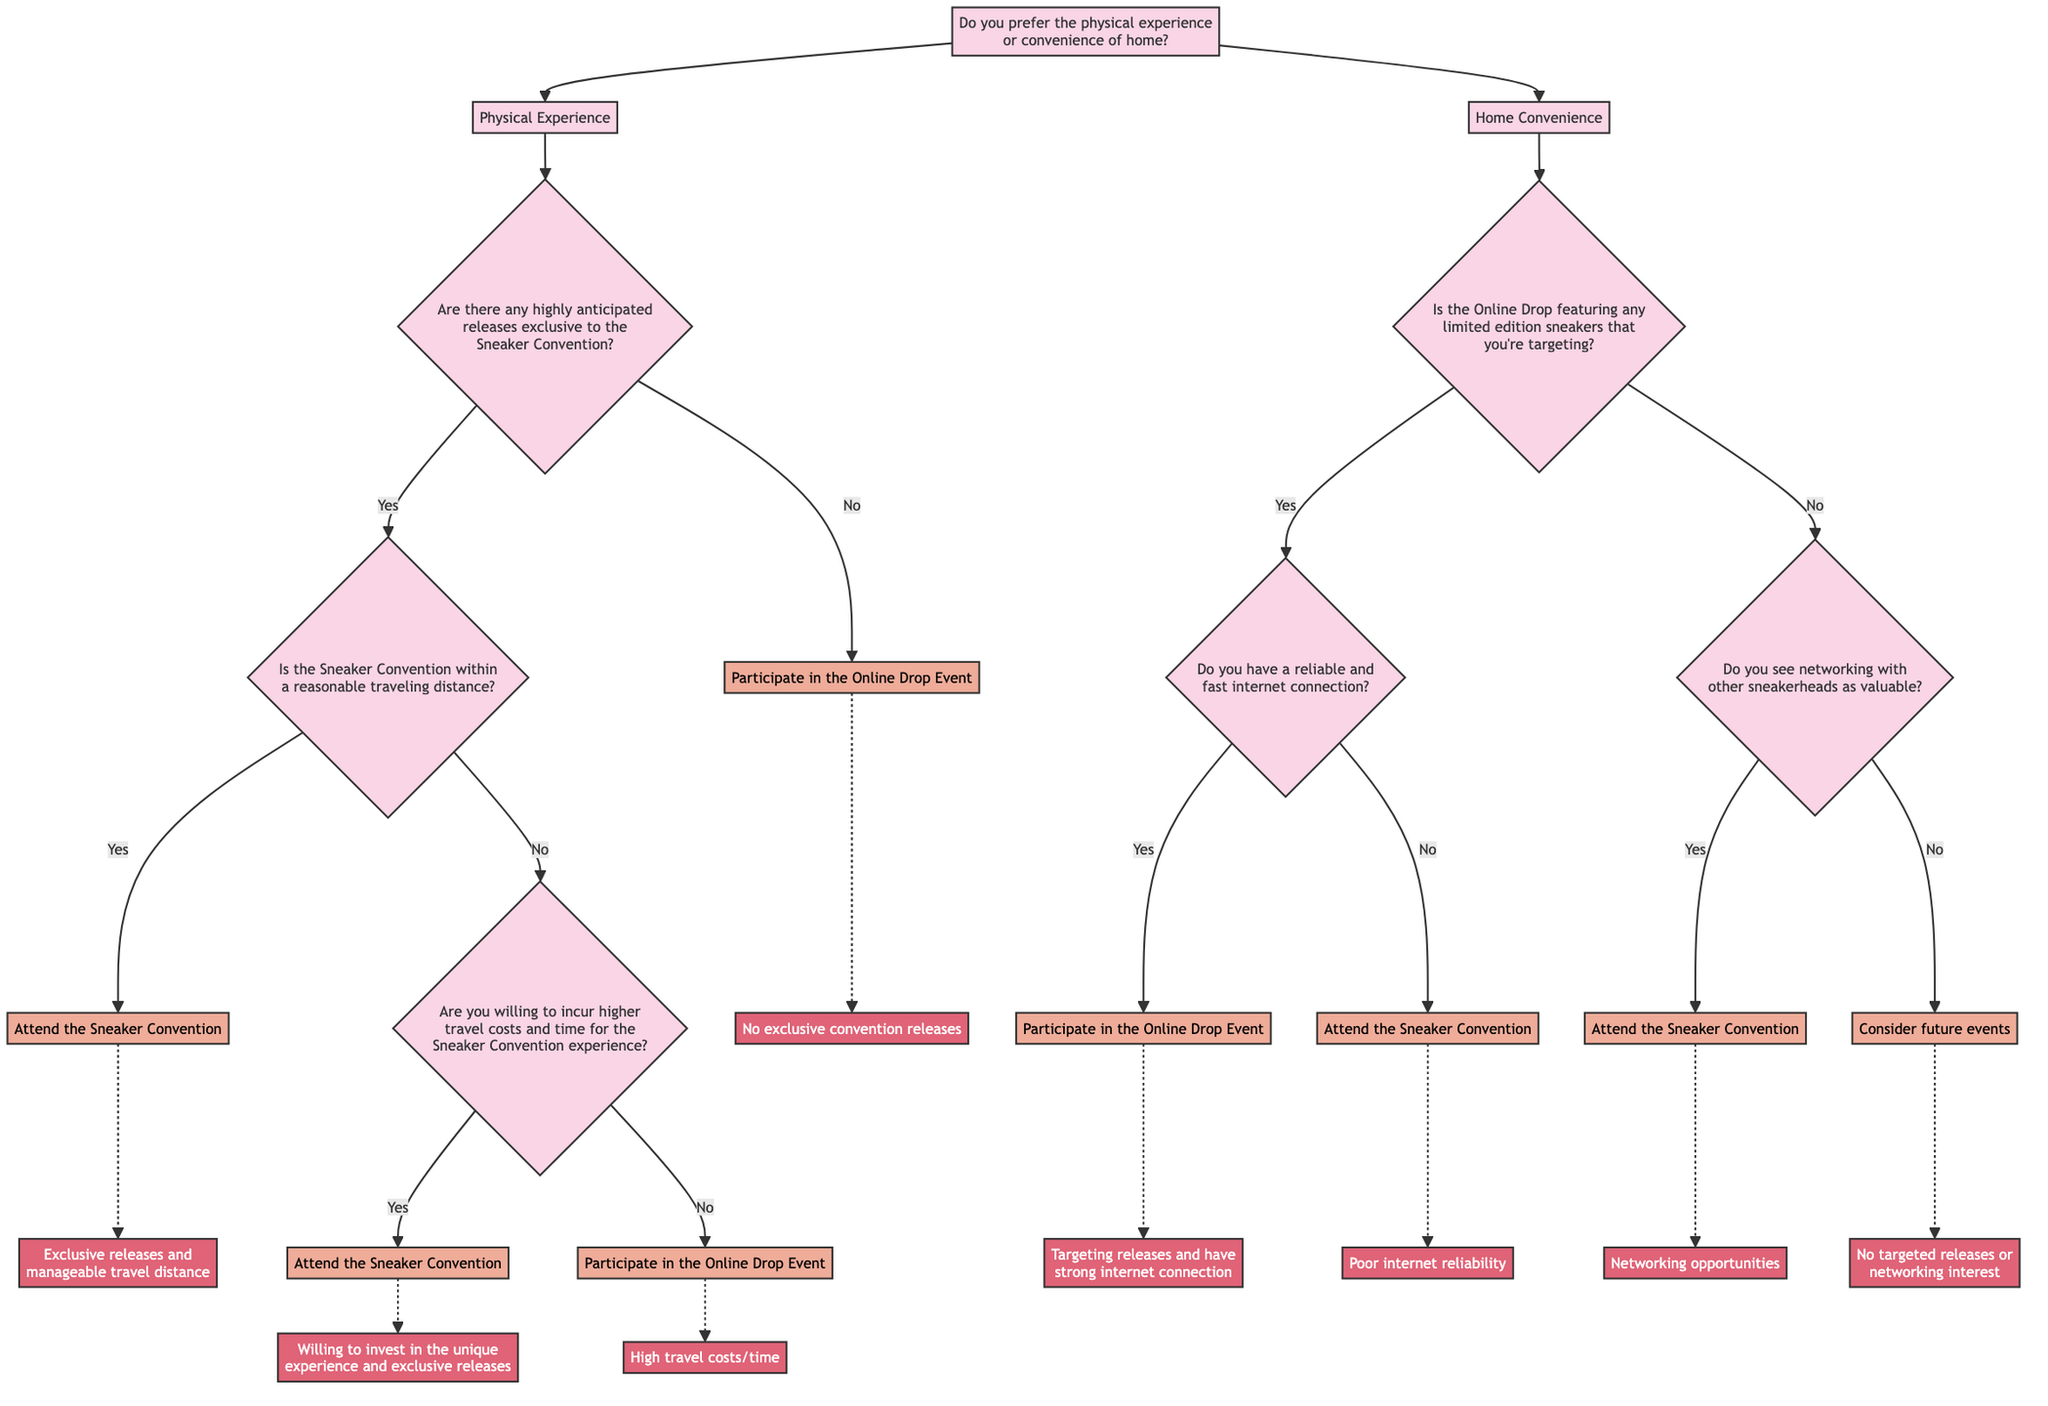What is the first question asked in the decision tree? The first question asked in the decision tree is "Do you prefer the physical experience or convenience of home?" as it initiates the decision-making process for attending either event.
Answer: Do you prefer the physical experience or convenience of home? How many total actions are indicated in the decision tree? By counting the unique actions represented in the diagram, there are five total actions: Attend the Sneaker Convention, Participate in the Online Drop Event, Consider future events, Attend the Sneaker Convention, and Participate in the Online Drop Event.
Answer: Five What is the path taken if someone prefers physical experience and is willing to incur higher travel costs? Starting at the first question, if the person prefers the physical experience, they are led to the question about exclusive releases. If they confirm exclusive releases and indicate higher travel cost willingness, the final action is to attend the Sneaker Convention.
Answer: Attend the Sneaker Convention What happens if the online drop features no limited edition sneakers? If there are no limited edition sneakers, the decision tree leads to evaluating the value of networking with other sneakerheads, which can further guide the decision to attend the Sneaker Convention or consider future events.
Answer: Consider future events If someone has a reliable internet connection, which action do they take when targeting online drop sneakers? If the person is targeting limited edition sneakers in the online drop and has a reliable internet connection, the decision tree directs them to participate in the online drop event.
Answer: Participate in the Online Drop Event What is the specific action taken if the Sneaker Convention is not within reasonable traveling distance and the person is not willing to incur higher costs? In this scenario, where the convention is not within a reasonable distance and the person is unwilling to take on higher travel costs, the decision tree indicates they should participate in the online drop event due to the high travel costs and time.
Answer: Participate in the Online Drop Event What value does the decision tree place on networking with other sneakerheads? The diagram indicates that if someone sees networking with other sneakerheads as valuable, they are guided to attend the Sneaker Convention, highlighting its importance in the decision-making process.
Answer: Attend the Sneaker Convention What is the outcome if both the online drop and the sneaker convention do not meet the person's interests? In this case, if there are neither targeted releases in the online drop nor interest in networking opportunities at the convention, the final action proposed by the decision tree is to consider future events, showing a lack of immediate interest.
Answer: Consider future events 